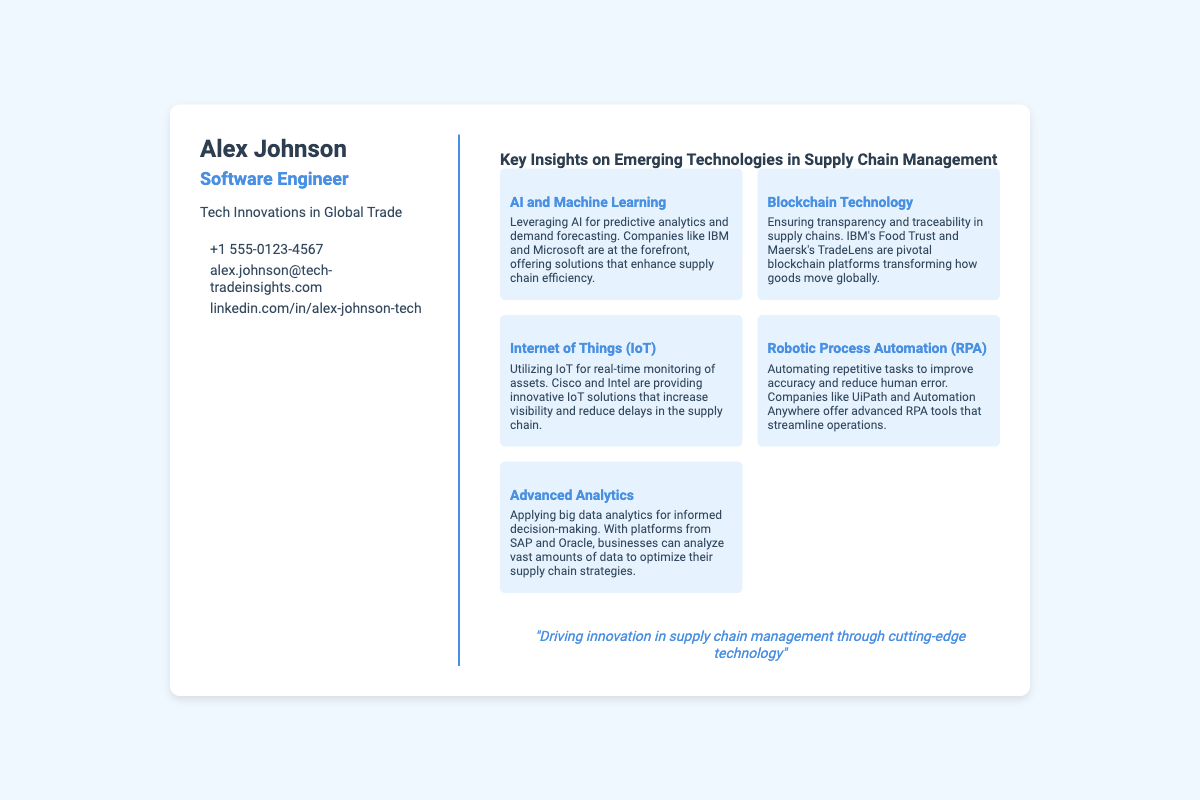What is the name of the individual on the business card? The document states the individual's name prominently at the top.
Answer: Alex Johnson What is Alex Johnson's profession? The document indicates his job title directly underneath his name.
Answer: Software Engineer What is the primary focus of Alex Johnson's work? The document includes a brief description of his area of expertise.
Answer: Tech Innovations in Global Trade Which company offers solutions that enhance supply chain efficiency? The document mentions specific companies that leverage AI for predictive analytics.
Answer: IBM and Microsoft What technology is associated with transparency and traceability in supply chains? The document lists this technology in the context of its application in supply chains.
Answer: Blockchain Technology Which company provides innovative IoT solutions to increase visibility? The document specifically names companies contributing to IoT advancements.
Answer: Cisco and Intel What is one of the advanced analytics platforms mentioned in the document? The document references specific companies that offer big data analytics platforms.
Answer: SAP and Oracle What is the quote given in the document? The document highlights a specific quote related to technology in supply chain management.
Answer: "Driving innovation in supply chain management through cutting-edge technology" How many key insights are provided in the document? The document lists specific categories of insights and can be counted.
Answer: Five 